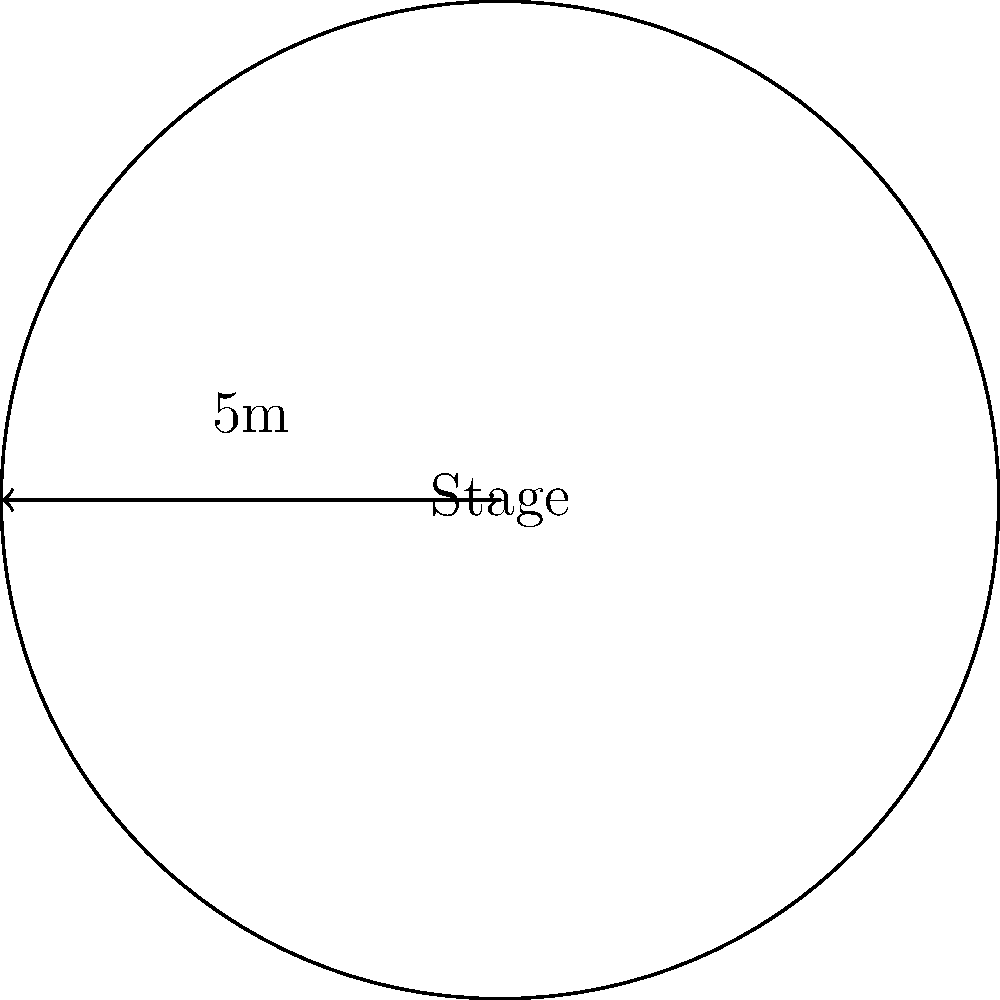Your punk band is planning a circular stage setup for an upcoming gig. The radius of the stage is 5 meters. What is the total area of the stage in square meters? Round your answer to the nearest whole number. To find the area of a circular stage, we need to use the formula for the area of a circle:

$$A = \pi r^2$$

Where:
$A$ = area of the circle
$\pi$ (pi) ≈ 3.14159
$r$ = radius of the circle

Given:
Radius ($r$) = 5 meters

Step 1: Substitute the values into the formula
$$A = \pi \times 5^2$$

Step 2: Calculate the square of the radius
$$A = \pi \times 25$$

Step 3: Multiply by $\pi$
$$A = 3.14159 \times 25 = 78.53975 \text{ m}^2$$

Step 4: Round to the nearest whole number
$$A \approx 79 \text{ m}^2$$

Therefore, the total area of the circular stage is approximately 79 square meters.
Answer: 79 m² 